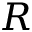<formula> <loc_0><loc_0><loc_500><loc_500>R</formula> 